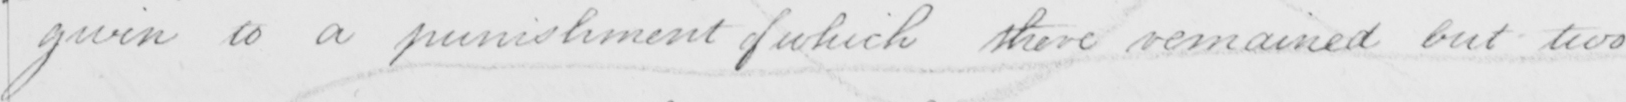Please transcribe the handwritten text in this image. given to a punishment of which there remained but two 